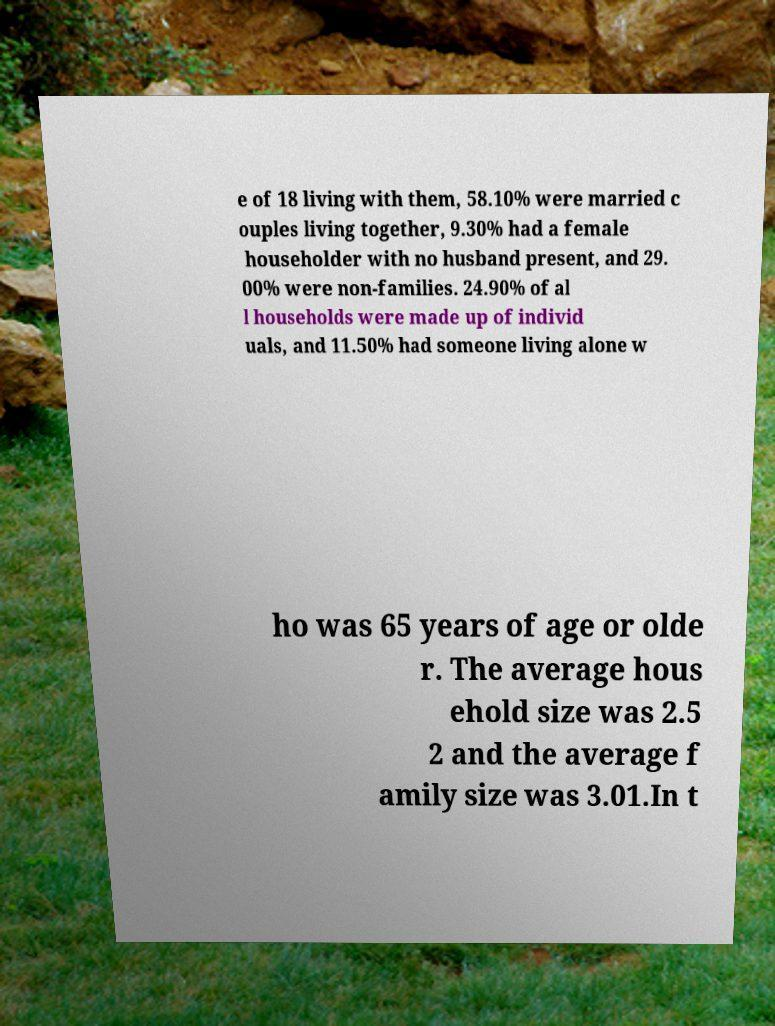Could you extract and type out the text from this image? e of 18 living with them, 58.10% were married c ouples living together, 9.30% had a female householder with no husband present, and 29. 00% were non-families. 24.90% of al l households were made up of individ uals, and 11.50% had someone living alone w ho was 65 years of age or olde r. The average hous ehold size was 2.5 2 and the average f amily size was 3.01.In t 